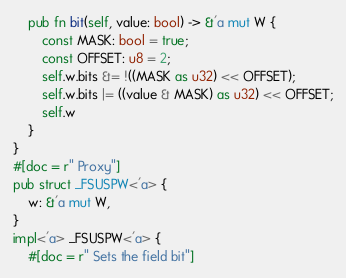Convert code to text. <code><loc_0><loc_0><loc_500><loc_500><_Rust_>    pub fn bit(self, value: bool) -> &'a mut W {
        const MASK: bool = true;
        const OFFSET: u8 = 2;
        self.w.bits &= !((MASK as u32) << OFFSET);
        self.w.bits |= ((value & MASK) as u32) << OFFSET;
        self.w
    }
}
#[doc = r" Proxy"]
pub struct _FSUSPW<'a> {
    w: &'a mut W,
}
impl<'a> _FSUSPW<'a> {
    #[doc = r" Sets the field bit"]</code> 